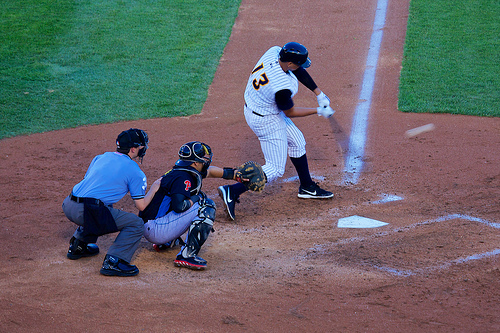Is the ball on the left or on the right? The ball is on the right, swiftly approaching the player with the bat. 